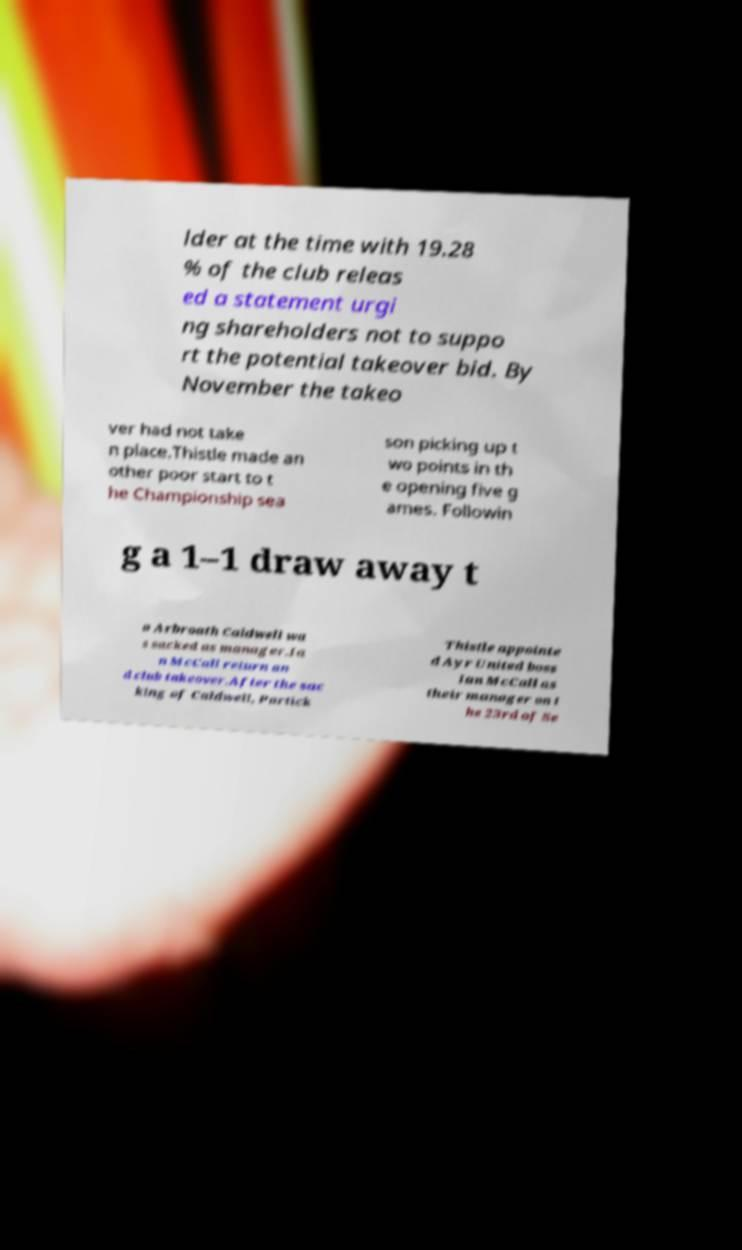Can you read and provide the text displayed in the image?This photo seems to have some interesting text. Can you extract and type it out for me? lder at the time with 19.28 % of the club releas ed a statement urgi ng shareholders not to suppo rt the potential takeover bid. By November the takeo ver had not take n place.Thistle made an other poor start to t he Championship sea son picking up t wo points in th e opening five g ames. Followin g a 1–1 draw away t o Arbroath Caldwell wa s sacked as manager.Ia n McCall return an d club takeover.After the sac king of Caldwell, Partick Thistle appointe d Ayr United boss Ian McCall as their manager on t he 23rd of Se 